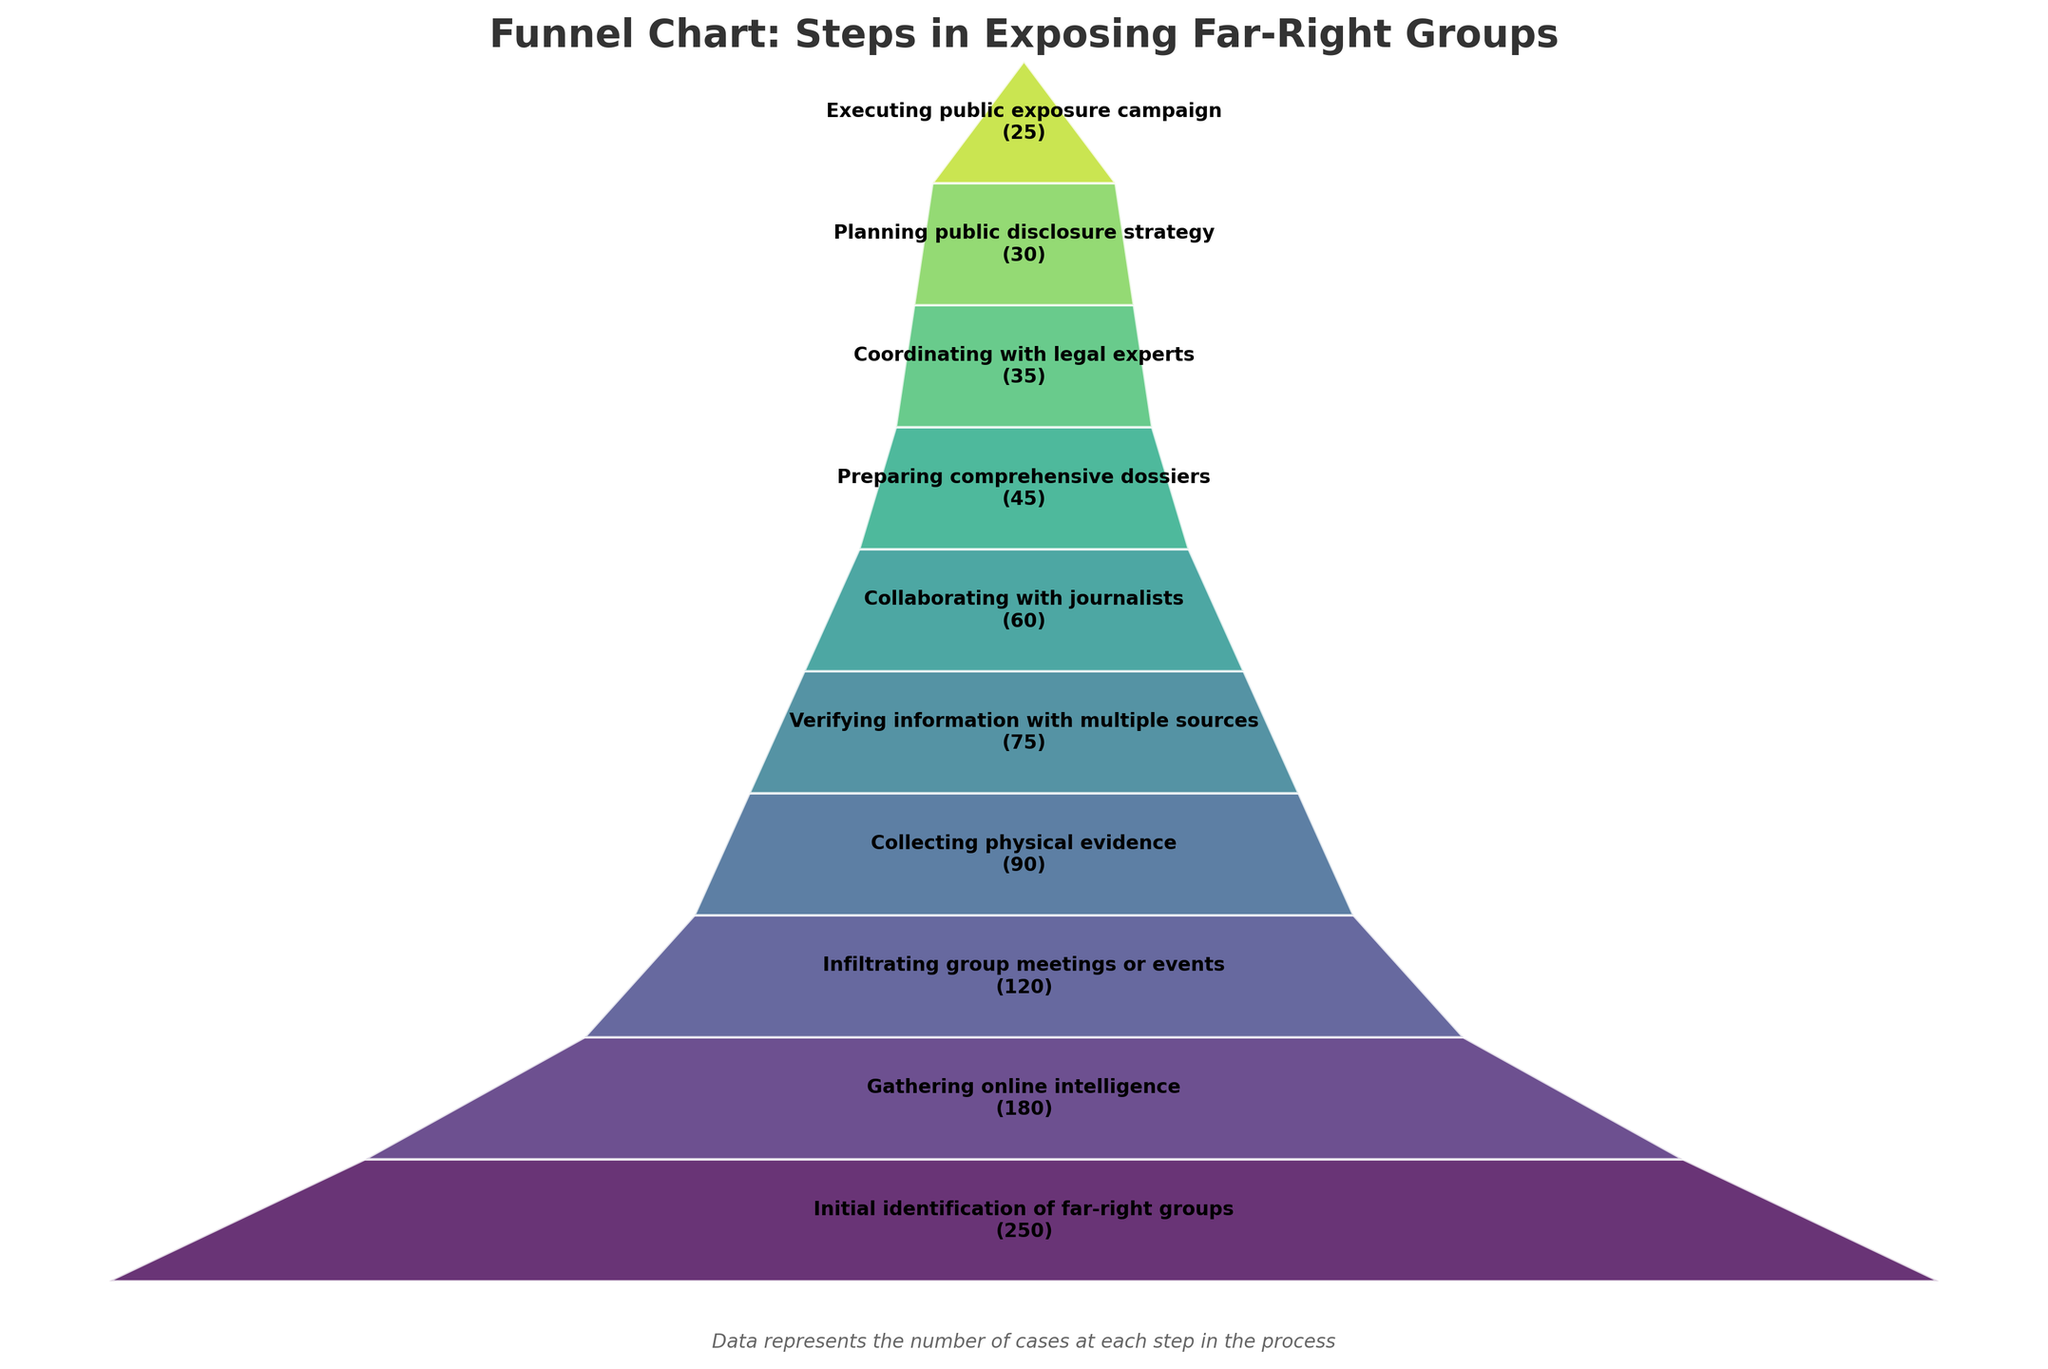What is the title of the funnel chart? The title is usually placed at the top of the chart and summarizes the content of the figure. The title in this chart reads "Funnel Chart: Steps in Exposing Far-Right Groups."
Answer: Funnel Chart: Steps in Exposing Far-Right Groups How many total steps are considered in this chart? By looking at the different segments in the funnel chart and counting the labels, it is possible to determine the number of distinct steps shown. There are 10 steps in total.
Answer: 10 Which step has the highest number of cases? The step with the highest number of cases will have the largest upper segment in the funnel. The step “Initial identification of far-right groups” has the highest number of cases with 250.
Answer: Initial identification of far-right groups How many cases are present in the last step of the process? The final step should be at the narrowest part of the funnel. The step for "Executing public exposure campaign" has 25 cases.
Answer: 25 How many cases are gathered in the step after online intelligence? The first thing is to identify the label after the "Gathering online intelligence" step, which is "Infiltrating group meetings or events." Then, check the number associated with it, which is 120.
Answer: 120 What is the difference in the number of cases between the 'Collecting physical evidence' and 'Collaborating with journalists' steps? Subtract the number at 'Collaborating with journalists' (60) from 'Collecting physical evidence' (90). The difference is 90 - 60 = 30.
Answer: 30 How many steps involve fewer than 50 cases? By examining each step and counting those with cases less than 50, the steps are “Preparing comprehensive dossiers” (45), “Coordinating with legal experts” (35), “Planning public disclosure strategy” (30), and “Executing public exposure campaign” (25). So there are 4 steps.
Answer: 4 Which step follows 'Coordinating with legal experts'? The next step in the process is immediately below 'Coordinating with legal experts.' It is “Planning public disclosure strategy.”
Answer: Planning public disclosure strategy What is the cumulative number of cases up to the 'Verifying information with multiple sources' step? Add the number of cases from the steps leading up to and including 'Verifying information with multiple sources': 250 + 180 + 120 + 90 + 75 = 715.
Answer: 715 